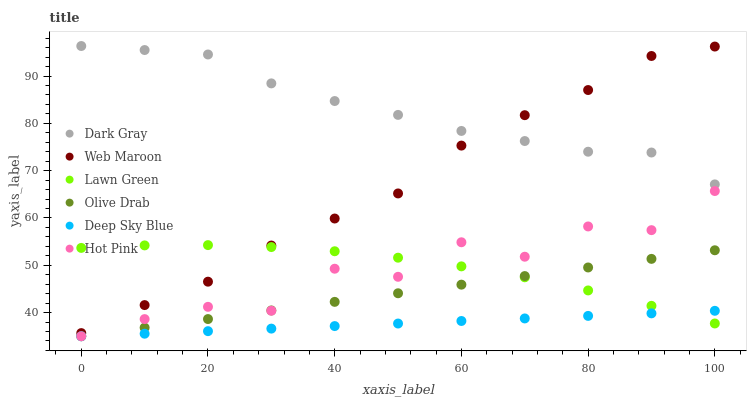Does Deep Sky Blue have the minimum area under the curve?
Answer yes or no. Yes. Does Dark Gray have the maximum area under the curve?
Answer yes or no. Yes. Does Hot Pink have the minimum area under the curve?
Answer yes or no. No. Does Hot Pink have the maximum area under the curve?
Answer yes or no. No. Is Olive Drab the smoothest?
Answer yes or no. Yes. Is Hot Pink the roughest?
Answer yes or no. Yes. Is Web Maroon the smoothest?
Answer yes or no. No. Is Web Maroon the roughest?
Answer yes or no. No. Does Hot Pink have the lowest value?
Answer yes or no. Yes. Does Web Maroon have the lowest value?
Answer yes or no. No. Does Dark Gray have the highest value?
Answer yes or no. Yes. Does Hot Pink have the highest value?
Answer yes or no. No. Is Olive Drab less than Web Maroon?
Answer yes or no. Yes. Is Web Maroon greater than Deep Sky Blue?
Answer yes or no. Yes. Does Lawn Green intersect Web Maroon?
Answer yes or no. Yes. Is Lawn Green less than Web Maroon?
Answer yes or no. No. Is Lawn Green greater than Web Maroon?
Answer yes or no. No. Does Olive Drab intersect Web Maroon?
Answer yes or no. No. 